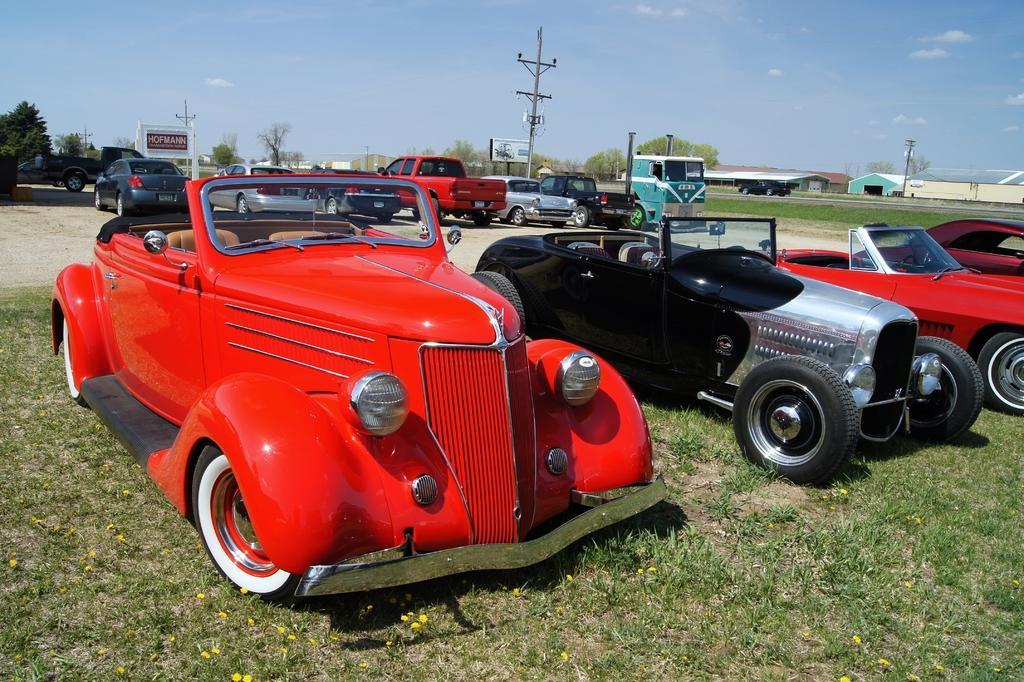Could you give a brief overview of what you see in this image? In this image I can see few vehicles on the grass. I can see the yellow color flowers to the grass. In the background I can see few more vehicles, poles and boards. I can see many trees, houses, clouds and the sky in the back. 